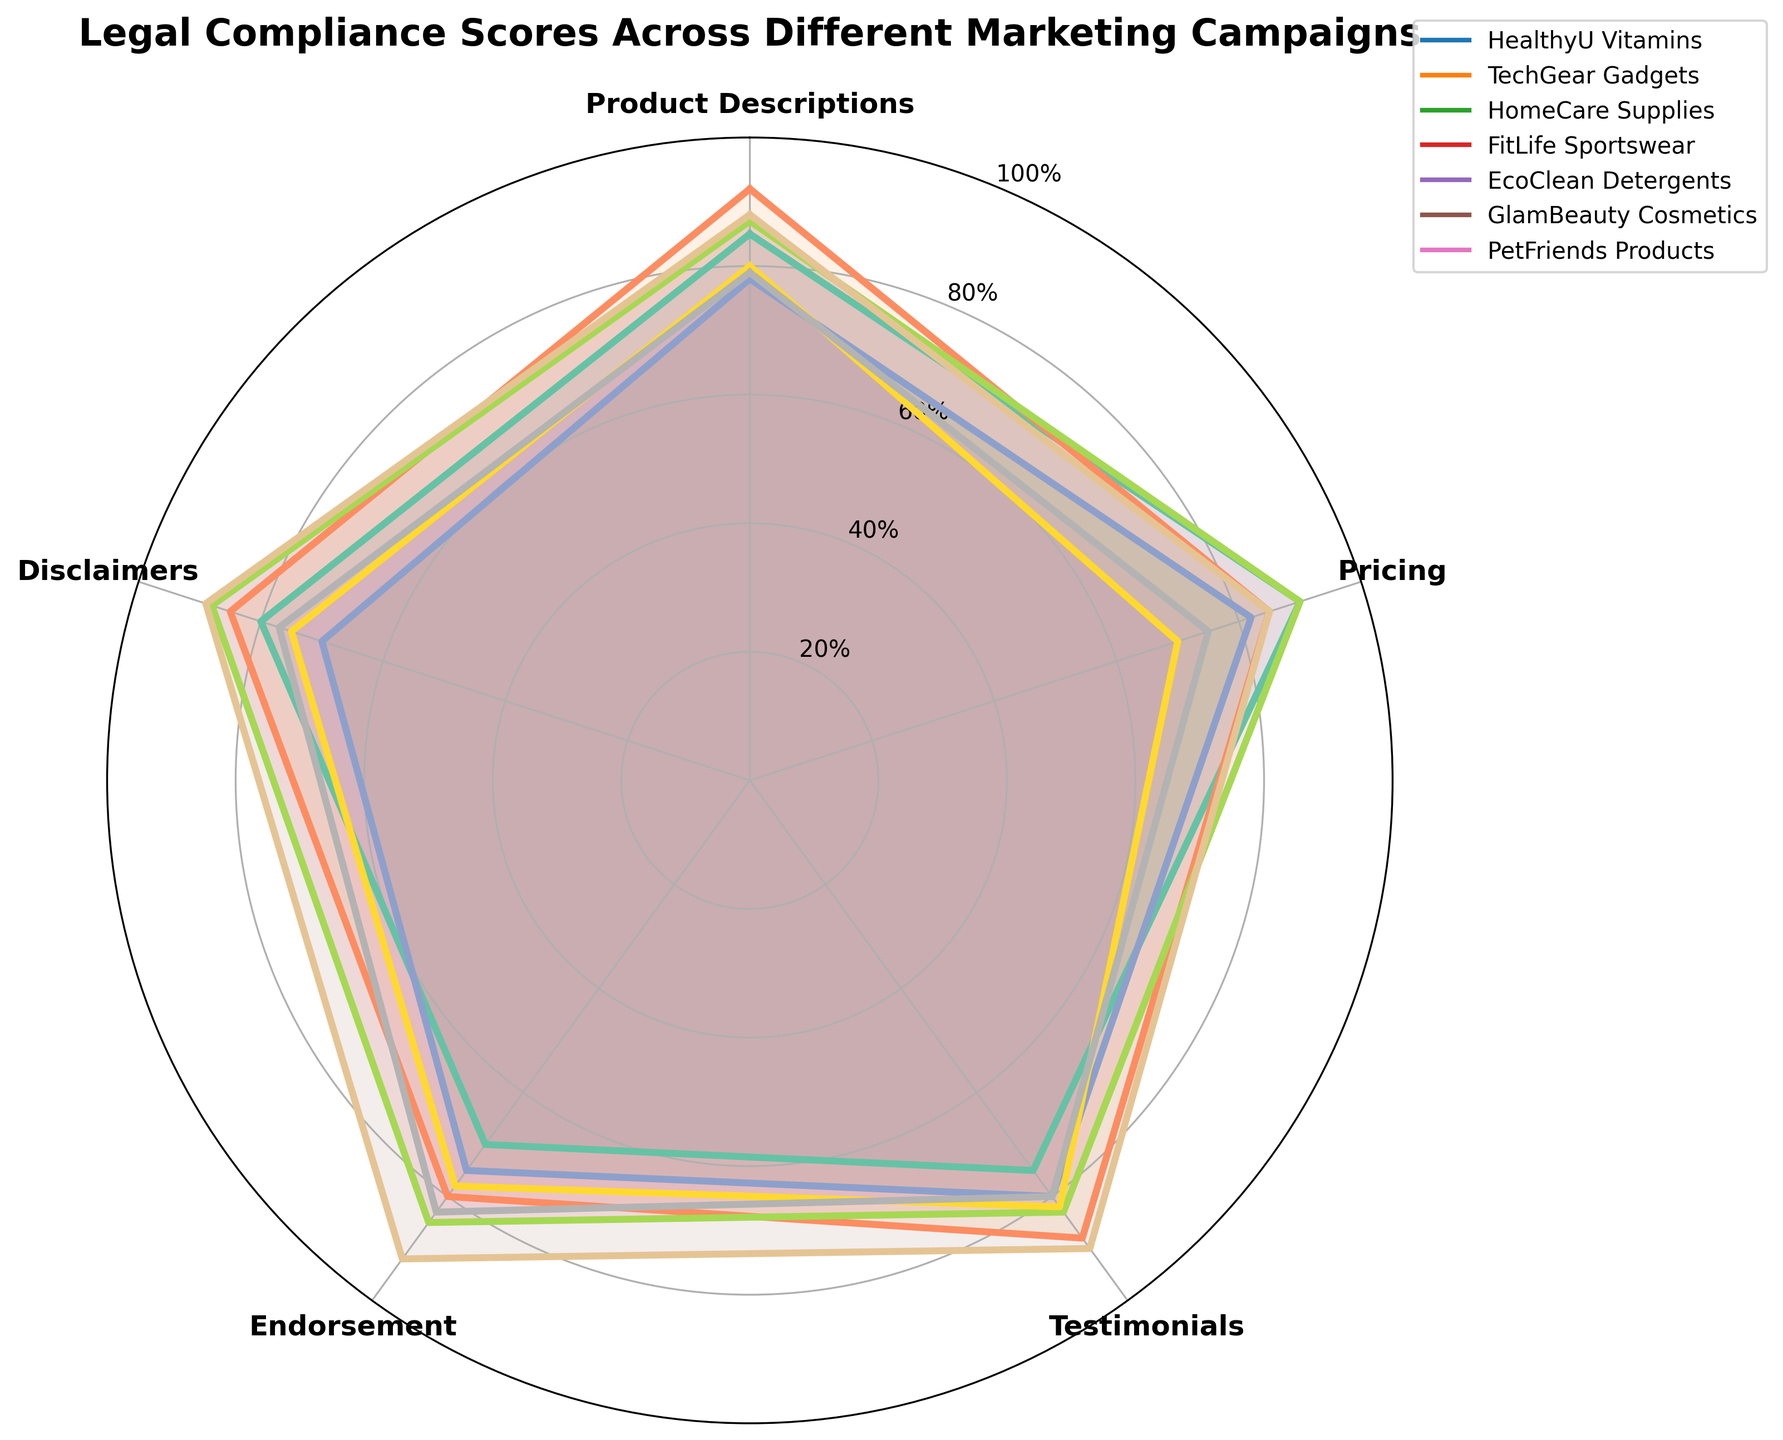What is the title of the chart? The title of the chart is displayed prominently at the top of the figure.
Answer: "Legal Compliance Scores Across Different Marketing Campaigns" Which campaign has the highest score in Testimonials? Locate the section labeled "Testimonials" and identify the highest point on this axis. The respective campaign is GlamBeauty Cosmetics.
Answer: GlamBeauty Cosmetics What are the scores for TechGear Gadgets in the Disclaimers and Pricing categories? Find the points corresponding to TechGear Gadgets and read off their values at the Disclaimers and Pricing axes.
Answer: 85 (Disclaimers), 85 (Pricing) Which category has the smallest range of scores across all campaigns? Calculate the difference between the maximum and minimum scores for each category and identify the category with the smallest range.
Answer: Endorsement Which campaign has the overall highest average score across all categories? Calculate the average score for each campaign across all five categories and compare them.
Answer: GlamBeauty Cosmetics What is the major difference between FitLife Sportswear and EcoClean Detergents in terms of compliance scores? Compare the radar chart shapes and note the significantly different scores. FitLife Sportswear has higher scores in Pricing, Testimonials, Endorsement, and Disclaimers.
Answer: FitLife Sportswear is generally higher Which two campaigns are most similar in their compliance scores? Analyze the shapes and positions of the plots for all campaigns. FitLife Sportswear and GlamBeauty Cosmetics have closely aligned plots.
Answer: FitLife Sportswear and GlamBeauty Cosmetics What is the average legal compliance score for HomeCare Supplies across all categories? Add up all scores for HomeCare Supplies and divide by the number of categories (5). (78+82+80+75+70)/5 = 77
Answer: 77 Which campaign has the lowest score in any category, and what is that score? Look for the lowest point among all categories for every campaign. The lowest is EcoClean Detergents in Pricing.
Answer: EcoClean Detergents, 70 